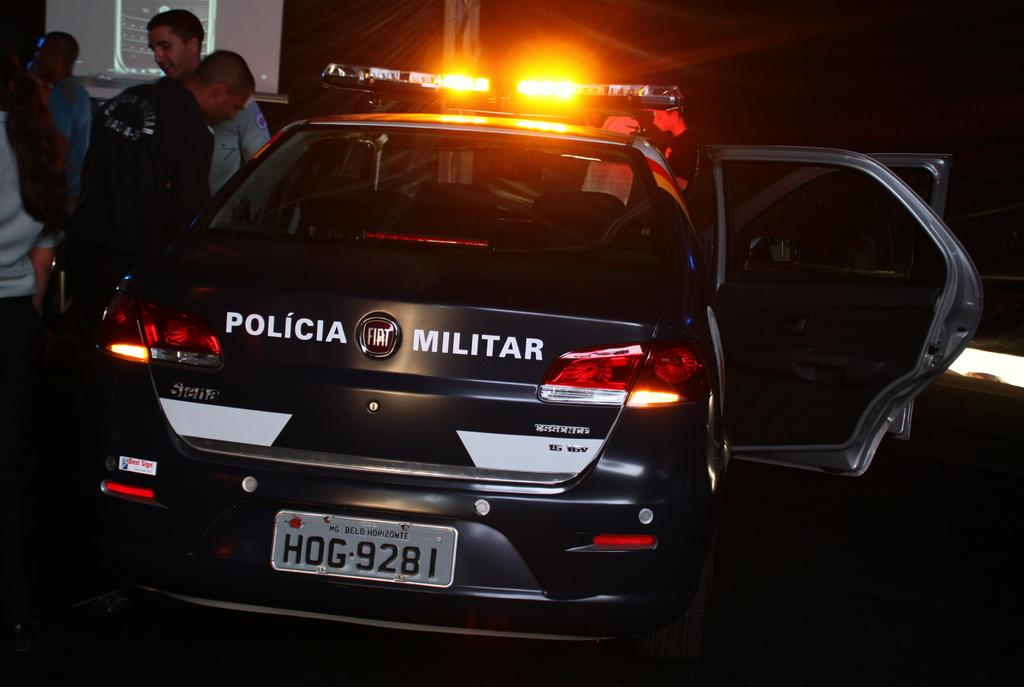Who or what is present in the image? There are people in the image. What type of vehicle can be seen in the image? There is a car in the image. What object in the image is used for displaying information or media? There is a screen in the image. How would you describe the lighting conditions in the image? The background of the image is dark, but there are lights visible in the background. What type of wall is present in the image? There is no wall present in the image. Can you see any wings on the people in the image? There is no mention of wings or any winged creatures in the image. Is there a scarecrow visible in the image? There is no scarecrow present in the image. 